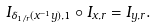Convert formula to latex. <formula><loc_0><loc_0><loc_500><loc_500>I _ { \delta _ { 1 / r } ( x ^ { - 1 } y ) , 1 } \circ I _ { x , r } = I _ { y , r } .</formula> 